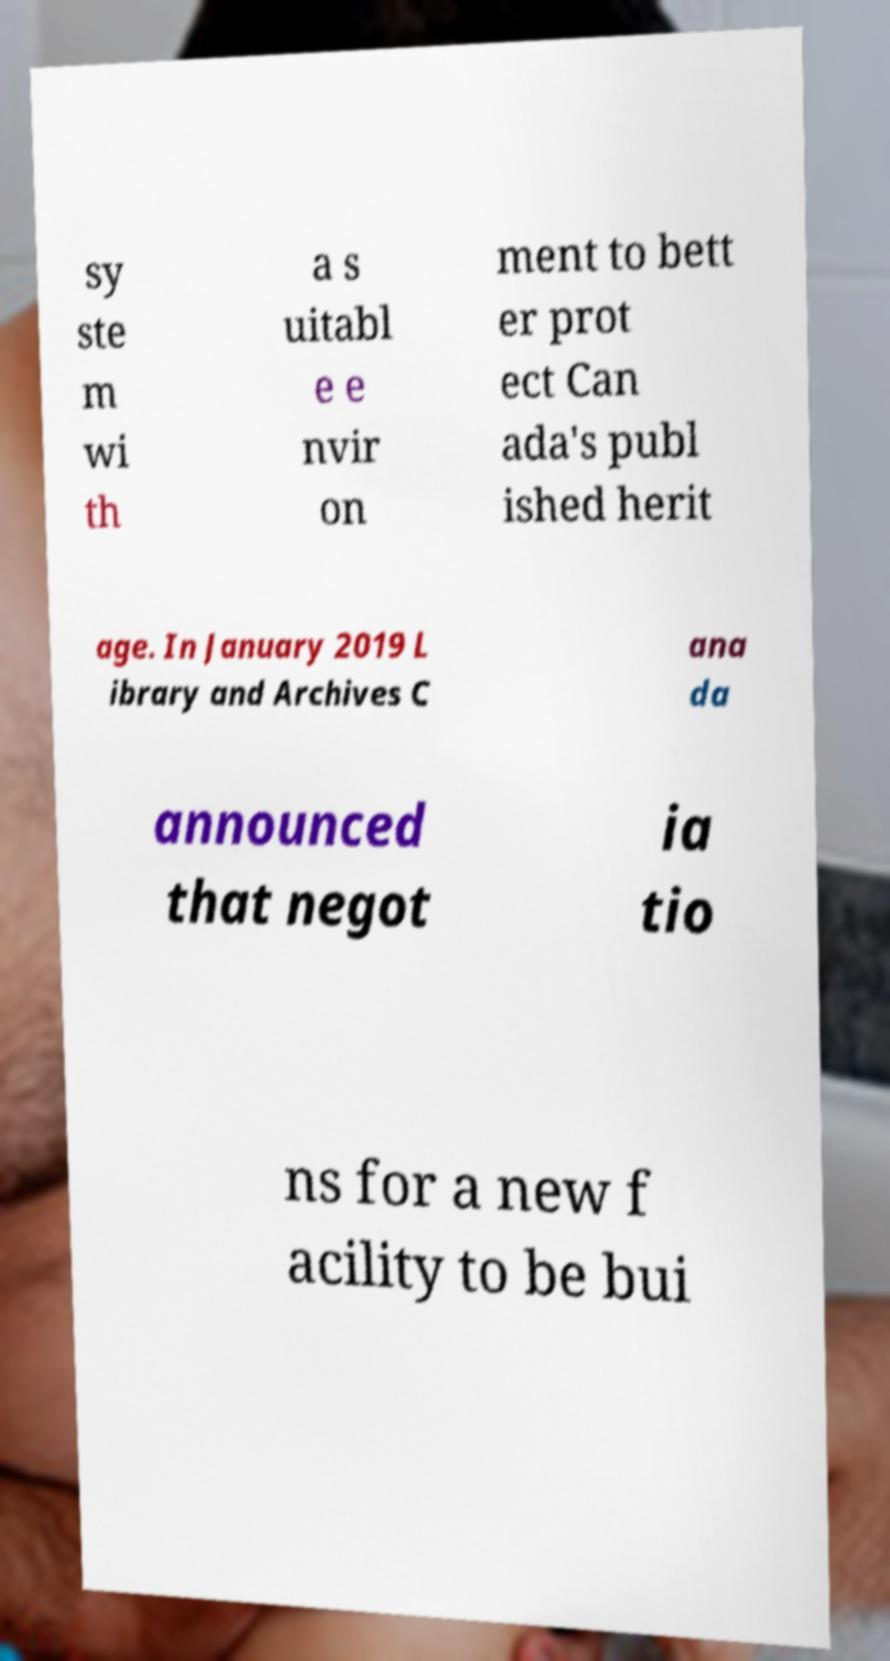Please read and relay the text visible in this image. What does it say? sy ste m wi th a s uitabl e e nvir on ment to bett er prot ect Can ada's publ ished herit age. In January 2019 L ibrary and Archives C ana da announced that negot ia tio ns for a new f acility to be bui 